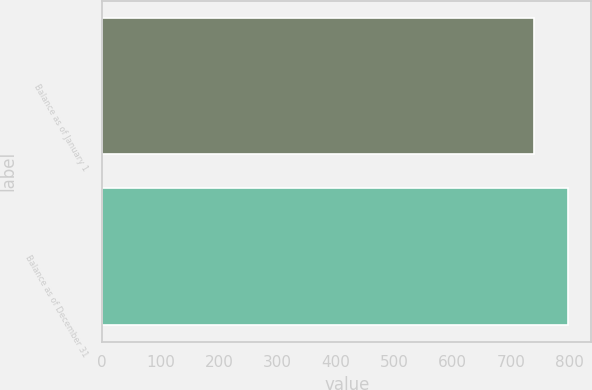<chart> <loc_0><loc_0><loc_500><loc_500><bar_chart><fcel>Balance as of January 1<fcel>Balance as of December 31<nl><fcel>739<fcel>797<nl></chart> 